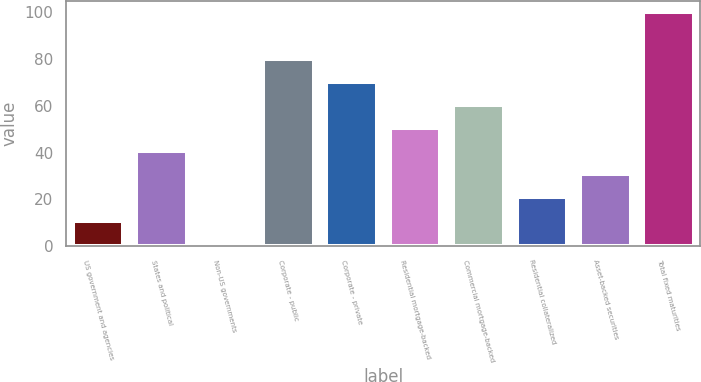Convert chart. <chart><loc_0><loc_0><loc_500><loc_500><bar_chart><fcel>US government and agencies<fcel>States and political<fcel>Non-US governments<fcel>Corporate - public<fcel>Corporate - private<fcel>Residential mortgage-backed<fcel>Commercial mortgage-backed<fcel>Residential collateralized<fcel>Asset-backed securities<fcel>Total fixed maturities<nl><fcel>10.9<fcel>40.6<fcel>1<fcel>80.2<fcel>70.3<fcel>50.5<fcel>60.4<fcel>20.8<fcel>30.7<fcel>100<nl></chart> 